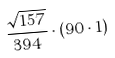<formula> <loc_0><loc_0><loc_500><loc_500>\frac { \sqrt { 1 5 7 } } { 3 9 4 } \cdot ( 9 0 \cdot 1 )</formula> 